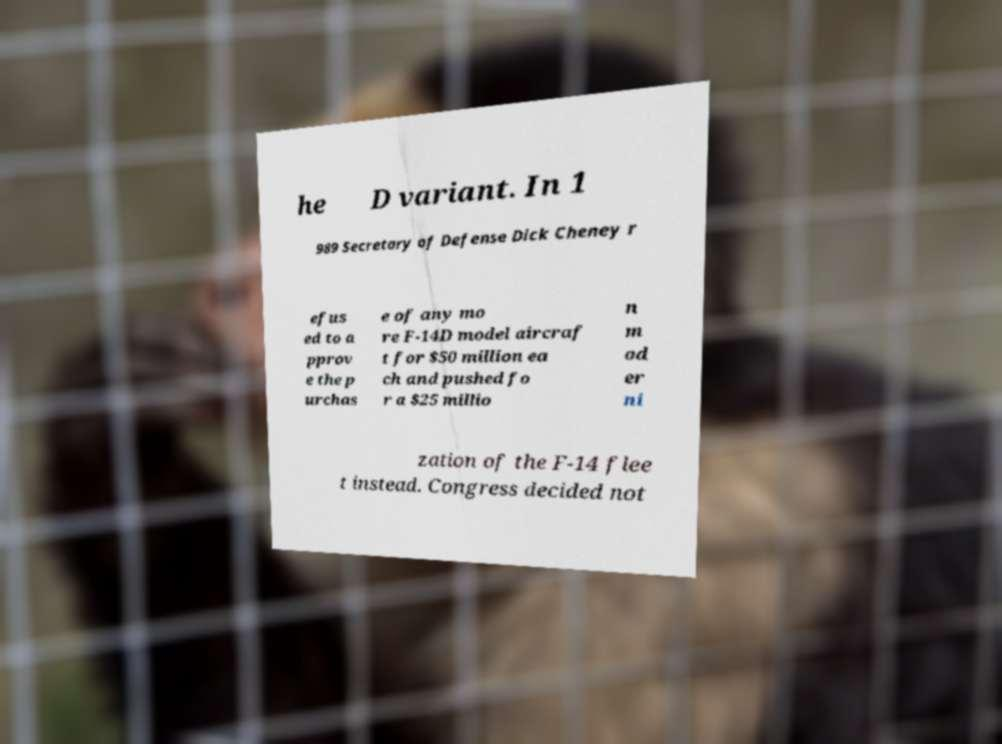There's text embedded in this image that I need extracted. Can you transcribe it verbatim? he D variant. In 1 989 Secretary of Defense Dick Cheney r efus ed to a pprov e the p urchas e of any mo re F-14D model aircraf t for $50 million ea ch and pushed fo r a $25 millio n m od er ni zation of the F-14 flee t instead. Congress decided not 